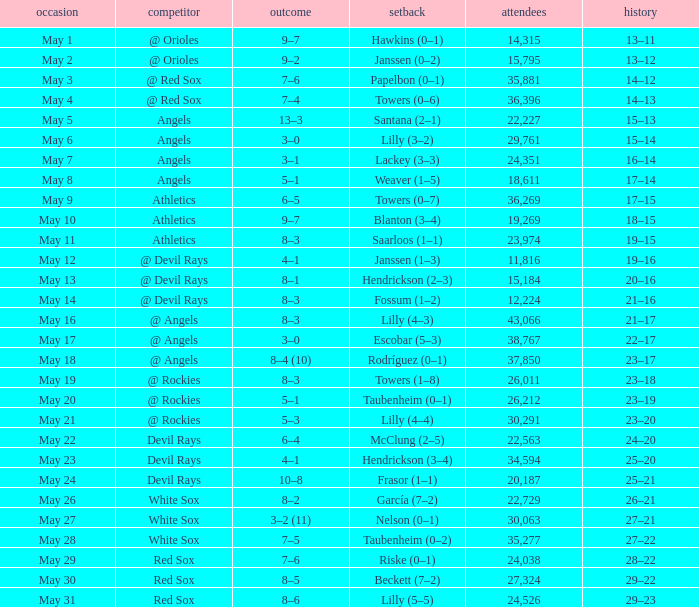What was the average attendance for games with a loss of papelbon (0–1)? 35881.0. 